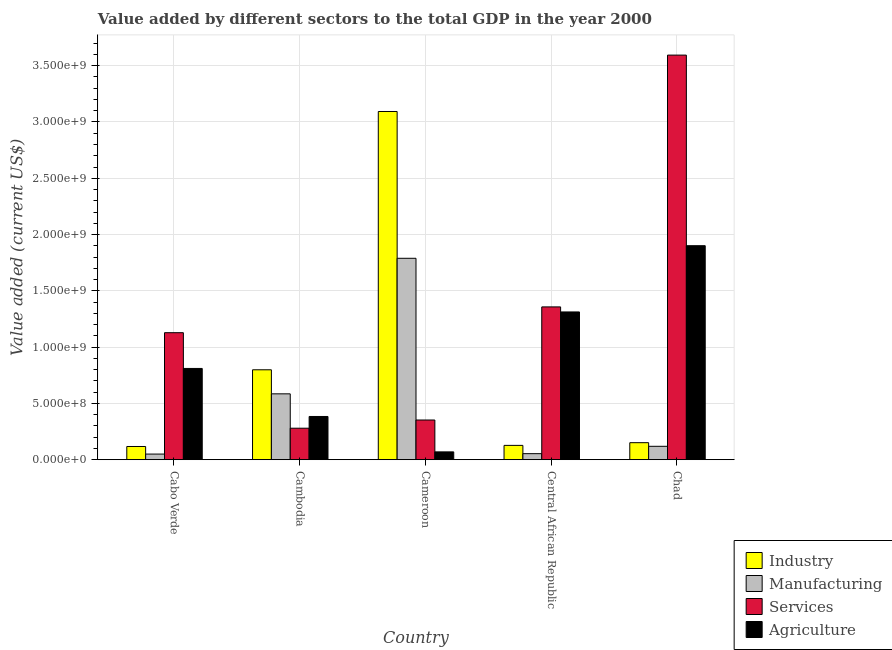How many different coloured bars are there?
Your response must be concise. 4. How many groups of bars are there?
Your response must be concise. 5. Are the number of bars on each tick of the X-axis equal?
Your answer should be very brief. Yes. What is the label of the 3rd group of bars from the left?
Keep it short and to the point. Cameroon. What is the value added by agricultural sector in Cabo Verde?
Give a very brief answer. 8.11e+08. Across all countries, what is the maximum value added by services sector?
Make the answer very short. 3.59e+09. Across all countries, what is the minimum value added by industrial sector?
Offer a terse response. 1.17e+08. In which country was the value added by services sector maximum?
Your answer should be compact. Chad. In which country was the value added by services sector minimum?
Make the answer very short. Cambodia. What is the total value added by services sector in the graph?
Offer a very short reply. 6.71e+09. What is the difference between the value added by services sector in Cambodia and that in Central African Republic?
Offer a terse response. -1.08e+09. What is the difference between the value added by manufacturing sector in Cambodia and the value added by industrial sector in Central African Republic?
Provide a short and direct response. 4.58e+08. What is the average value added by industrial sector per country?
Ensure brevity in your answer.  8.57e+08. What is the difference between the value added by industrial sector and value added by agricultural sector in Central African Republic?
Make the answer very short. -1.19e+09. In how many countries, is the value added by manufacturing sector greater than 1700000000 US$?
Your answer should be compact. 1. What is the ratio of the value added by manufacturing sector in Cambodia to that in Cameroon?
Your response must be concise. 0.33. What is the difference between the highest and the second highest value added by manufacturing sector?
Provide a succinct answer. 1.20e+09. What is the difference between the highest and the lowest value added by services sector?
Your answer should be very brief. 3.31e+09. Is the sum of the value added by manufacturing sector in Cabo Verde and Chad greater than the maximum value added by agricultural sector across all countries?
Provide a short and direct response. No. What does the 2nd bar from the left in Cambodia represents?
Give a very brief answer. Manufacturing. What does the 2nd bar from the right in Cabo Verde represents?
Your answer should be compact. Services. How many bars are there?
Offer a very short reply. 20. Are all the bars in the graph horizontal?
Make the answer very short. No. How many countries are there in the graph?
Provide a short and direct response. 5. Are the values on the major ticks of Y-axis written in scientific E-notation?
Your answer should be very brief. Yes. Does the graph contain any zero values?
Keep it short and to the point. No. Does the graph contain grids?
Your answer should be compact. Yes. What is the title of the graph?
Your answer should be very brief. Value added by different sectors to the total GDP in the year 2000. What is the label or title of the X-axis?
Keep it short and to the point. Country. What is the label or title of the Y-axis?
Your response must be concise. Value added (current US$). What is the Value added (current US$) of Industry in Cabo Verde?
Provide a succinct answer. 1.17e+08. What is the Value added (current US$) in Manufacturing in Cabo Verde?
Make the answer very short. 4.99e+07. What is the Value added (current US$) of Services in Cabo Verde?
Offer a very short reply. 1.13e+09. What is the Value added (current US$) in Agriculture in Cabo Verde?
Offer a very short reply. 8.11e+08. What is the Value added (current US$) of Industry in Cambodia?
Provide a succinct answer. 7.99e+08. What is the Value added (current US$) of Manufacturing in Cambodia?
Make the answer very short. 5.85e+08. What is the Value added (current US$) in Services in Cambodia?
Keep it short and to the point. 2.80e+08. What is the Value added (current US$) of Agriculture in Cambodia?
Your response must be concise. 3.84e+08. What is the Value added (current US$) of Industry in Cameroon?
Give a very brief answer. 3.09e+09. What is the Value added (current US$) in Manufacturing in Cameroon?
Offer a terse response. 1.79e+09. What is the Value added (current US$) in Services in Cameroon?
Your answer should be compact. 3.53e+08. What is the Value added (current US$) of Agriculture in Cameroon?
Offer a terse response. 6.94e+07. What is the Value added (current US$) of Industry in Central African Republic?
Your response must be concise. 1.27e+08. What is the Value added (current US$) of Manufacturing in Central African Republic?
Your response must be concise. 5.35e+07. What is the Value added (current US$) of Services in Central African Republic?
Provide a short and direct response. 1.36e+09. What is the Value added (current US$) in Agriculture in Central African Republic?
Ensure brevity in your answer.  1.31e+09. What is the Value added (current US$) of Industry in Chad?
Offer a terse response. 1.51e+08. What is the Value added (current US$) in Manufacturing in Chad?
Give a very brief answer. 1.19e+08. What is the Value added (current US$) in Services in Chad?
Ensure brevity in your answer.  3.59e+09. What is the Value added (current US$) of Agriculture in Chad?
Ensure brevity in your answer.  1.90e+09. Across all countries, what is the maximum Value added (current US$) in Industry?
Offer a very short reply. 3.09e+09. Across all countries, what is the maximum Value added (current US$) of Manufacturing?
Provide a short and direct response. 1.79e+09. Across all countries, what is the maximum Value added (current US$) of Services?
Provide a short and direct response. 3.59e+09. Across all countries, what is the maximum Value added (current US$) in Agriculture?
Your response must be concise. 1.90e+09. Across all countries, what is the minimum Value added (current US$) in Industry?
Keep it short and to the point. 1.17e+08. Across all countries, what is the minimum Value added (current US$) in Manufacturing?
Keep it short and to the point. 4.99e+07. Across all countries, what is the minimum Value added (current US$) in Services?
Offer a terse response. 2.80e+08. Across all countries, what is the minimum Value added (current US$) of Agriculture?
Provide a short and direct response. 6.94e+07. What is the total Value added (current US$) of Industry in the graph?
Keep it short and to the point. 4.29e+09. What is the total Value added (current US$) in Manufacturing in the graph?
Offer a very short reply. 2.60e+09. What is the total Value added (current US$) of Services in the graph?
Give a very brief answer. 6.71e+09. What is the total Value added (current US$) of Agriculture in the graph?
Offer a very short reply. 4.48e+09. What is the difference between the Value added (current US$) of Industry in Cabo Verde and that in Cambodia?
Make the answer very short. -6.81e+08. What is the difference between the Value added (current US$) in Manufacturing in Cabo Verde and that in Cambodia?
Your response must be concise. -5.35e+08. What is the difference between the Value added (current US$) of Services in Cabo Verde and that in Cambodia?
Provide a succinct answer. 8.49e+08. What is the difference between the Value added (current US$) in Agriculture in Cabo Verde and that in Cambodia?
Give a very brief answer. 4.27e+08. What is the difference between the Value added (current US$) in Industry in Cabo Verde and that in Cameroon?
Provide a succinct answer. -2.98e+09. What is the difference between the Value added (current US$) of Manufacturing in Cabo Verde and that in Cameroon?
Your answer should be very brief. -1.74e+09. What is the difference between the Value added (current US$) in Services in Cabo Verde and that in Cameroon?
Your answer should be compact. 7.76e+08. What is the difference between the Value added (current US$) in Agriculture in Cabo Verde and that in Cameroon?
Your answer should be very brief. 7.41e+08. What is the difference between the Value added (current US$) of Industry in Cabo Verde and that in Central African Republic?
Keep it short and to the point. -9.83e+06. What is the difference between the Value added (current US$) in Manufacturing in Cabo Verde and that in Central African Republic?
Your response must be concise. -3.60e+06. What is the difference between the Value added (current US$) in Services in Cabo Verde and that in Central African Republic?
Provide a succinct answer. -2.29e+08. What is the difference between the Value added (current US$) in Agriculture in Cabo Verde and that in Central African Republic?
Make the answer very short. -5.02e+08. What is the difference between the Value added (current US$) in Industry in Cabo Verde and that in Chad?
Provide a succinct answer. -3.39e+07. What is the difference between the Value added (current US$) of Manufacturing in Cabo Verde and that in Chad?
Your answer should be very brief. -6.90e+07. What is the difference between the Value added (current US$) in Services in Cabo Verde and that in Chad?
Provide a succinct answer. -2.47e+09. What is the difference between the Value added (current US$) of Agriculture in Cabo Verde and that in Chad?
Give a very brief answer. -1.09e+09. What is the difference between the Value added (current US$) in Industry in Cambodia and that in Cameroon?
Offer a very short reply. -2.29e+09. What is the difference between the Value added (current US$) of Manufacturing in Cambodia and that in Cameroon?
Provide a succinct answer. -1.20e+09. What is the difference between the Value added (current US$) of Services in Cambodia and that in Cameroon?
Provide a succinct answer. -7.29e+07. What is the difference between the Value added (current US$) of Agriculture in Cambodia and that in Cameroon?
Offer a terse response. 3.15e+08. What is the difference between the Value added (current US$) in Industry in Cambodia and that in Central African Republic?
Make the answer very short. 6.72e+08. What is the difference between the Value added (current US$) in Manufacturing in Cambodia and that in Central African Republic?
Your answer should be very brief. 5.31e+08. What is the difference between the Value added (current US$) of Services in Cambodia and that in Central African Republic?
Your answer should be very brief. -1.08e+09. What is the difference between the Value added (current US$) of Agriculture in Cambodia and that in Central African Republic?
Your response must be concise. -9.29e+08. What is the difference between the Value added (current US$) in Industry in Cambodia and that in Chad?
Offer a very short reply. 6.48e+08. What is the difference between the Value added (current US$) of Manufacturing in Cambodia and that in Chad?
Provide a short and direct response. 4.66e+08. What is the difference between the Value added (current US$) of Services in Cambodia and that in Chad?
Make the answer very short. -3.31e+09. What is the difference between the Value added (current US$) in Agriculture in Cambodia and that in Chad?
Provide a succinct answer. -1.52e+09. What is the difference between the Value added (current US$) in Industry in Cameroon and that in Central African Republic?
Ensure brevity in your answer.  2.97e+09. What is the difference between the Value added (current US$) of Manufacturing in Cameroon and that in Central African Republic?
Make the answer very short. 1.74e+09. What is the difference between the Value added (current US$) of Services in Cameroon and that in Central African Republic?
Keep it short and to the point. -1.00e+09. What is the difference between the Value added (current US$) of Agriculture in Cameroon and that in Central African Republic?
Keep it short and to the point. -1.24e+09. What is the difference between the Value added (current US$) of Industry in Cameroon and that in Chad?
Ensure brevity in your answer.  2.94e+09. What is the difference between the Value added (current US$) in Manufacturing in Cameroon and that in Chad?
Offer a terse response. 1.67e+09. What is the difference between the Value added (current US$) of Services in Cameroon and that in Chad?
Provide a succinct answer. -3.24e+09. What is the difference between the Value added (current US$) in Agriculture in Cameroon and that in Chad?
Your answer should be very brief. -1.83e+09. What is the difference between the Value added (current US$) of Industry in Central African Republic and that in Chad?
Your response must be concise. -2.40e+07. What is the difference between the Value added (current US$) of Manufacturing in Central African Republic and that in Chad?
Offer a terse response. -6.54e+07. What is the difference between the Value added (current US$) in Services in Central African Republic and that in Chad?
Provide a short and direct response. -2.24e+09. What is the difference between the Value added (current US$) of Agriculture in Central African Republic and that in Chad?
Your answer should be compact. -5.88e+08. What is the difference between the Value added (current US$) in Industry in Cabo Verde and the Value added (current US$) in Manufacturing in Cambodia?
Your response must be concise. -4.68e+08. What is the difference between the Value added (current US$) of Industry in Cabo Verde and the Value added (current US$) of Services in Cambodia?
Provide a succinct answer. -1.62e+08. What is the difference between the Value added (current US$) of Industry in Cabo Verde and the Value added (current US$) of Agriculture in Cambodia?
Provide a short and direct response. -2.67e+08. What is the difference between the Value added (current US$) of Manufacturing in Cabo Verde and the Value added (current US$) of Services in Cambodia?
Your answer should be compact. -2.30e+08. What is the difference between the Value added (current US$) of Manufacturing in Cabo Verde and the Value added (current US$) of Agriculture in Cambodia?
Your answer should be compact. -3.34e+08. What is the difference between the Value added (current US$) of Services in Cabo Verde and the Value added (current US$) of Agriculture in Cambodia?
Your answer should be very brief. 7.44e+08. What is the difference between the Value added (current US$) in Industry in Cabo Verde and the Value added (current US$) in Manufacturing in Cameroon?
Make the answer very short. -1.67e+09. What is the difference between the Value added (current US$) in Industry in Cabo Verde and the Value added (current US$) in Services in Cameroon?
Provide a short and direct response. -2.35e+08. What is the difference between the Value added (current US$) of Industry in Cabo Verde and the Value added (current US$) of Agriculture in Cameroon?
Give a very brief answer. 4.79e+07. What is the difference between the Value added (current US$) of Manufacturing in Cabo Verde and the Value added (current US$) of Services in Cameroon?
Provide a short and direct response. -3.03e+08. What is the difference between the Value added (current US$) in Manufacturing in Cabo Verde and the Value added (current US$) in Agriculture in Cameroon?
Make the answer very short. -1.95e+07. What is the difference between the Value added (current US$) of Services in Cabo Verde and the Value added (current US$) of Agriculture in Cameroon?
Your answer should be very brief. 1.06e+09. What is the difference between the Value added (current US$) of Industry in Cabo Verde and the Value added (current US$) of Manufacturing in Central African Republic?
Your response must be concise. 6.37e+07. What is the difference between the Value added (current US$) of Industry in Cabo Verde and the Value added (current US$) of Services in Central African Republic?
Provide a succinct answer. -1.24e+09. What is the difference between the Value added (current US$) in Industry in Cabo Verde and the Value added (current US$) in Agriculture in Central African Republic?
Provide a succinct answer. -1.20e+09. What is the difference between the Value added (current US$) in Manufacturing in Cabo Verde and the Value added (current US$) in Services in Central African Republic?
Ensure brevity in your answer.  -1.31e+09. What is the difference between the Value added (current US$) of Manufacturing in Cabo Verde and the Value added (current US$) of Agriculture in Central African Republic?
Keep it short and to the point. -1.26e+09. What is the difference between the Value added (current US$) in Services in Cabo Verde and the Value added (current US$) in Agriculture in Central African Republic?
Provide a short and direct response. -1.84e+08. What is the difference between the Value added (current US$) in Industry in Cabo Verde and the Value added (current US$) in Manufacturing in Chad?
Your answer should be compact. -1.68e+06. What is the difference between the Value added (current US$) of Industry in Cabo Verde and the Value added (current US$) of Services in Chad?
Make the answer very short. -3.48e+09. What is the difference between the Value added (current US$) of Industry in Cabo Verde and the Value added (current US$) of Agriculture in Chad?
Your response must be concise. -1.78e+09. What is the difference between the Value added (current US$) in Manufacturing in Cabo Verde and the Value added (current US$) in Services in Chad?
Keep it short and to the point. -3.54e+09. What is the difference between the Value added (current US$) of Manufacturing in Cabo Verde and the Value added (current US$) of Agriculture in Chad?
Your answer should be compact. -1.85e+09. What is the difference between the Value added (current US$) of Services in Cabo Verde and the Value added (current US$) of Agriculture in Chad?
Offer a very short reply. -7.73e+08. What is the difference between the Value added (current US$) in Industry in Cambodia and the Value added (current US$) in Manufacturing in Cameroon?
Make the answer very short. -9.90e+08. What is the difference between the Value added (current US$) in Industry in Cambodia and the Value added (current US$) in Services in Cameroon?
Your answer should be compact. 4.46e+08. What is the difference between the Value added (current US$) in Industry in Cambodia and the Value added (current US$) in Agriculture in Cameroon?
Offer a very short reply. 7.29e+08. What is the difference between the Value added (current US$) of Manufacturing in Cambodia and the Value added (current US$) of Services in Cameroon?
Provide a short and direct response. 2.32e+08. What is the difference between the Value added (current US$) of Manufacturing in Cambodia and the Value added (current US$) of Agriculture in Cameroon?
Make the answer very short. 5.16e+08. What is the difference between the Value added (current US$) of Services in Cambodia and the Value added (current US$) of Agriculture in Cameroon?
Your answer should be very brief. 2.10e+08. What is the difference between the Value added (current US$) in Industry in Cambodia and the Value added (current US$) in Manufacturing in Central African Republic?
Keep it short and to the point. 7.45e+08. What is the difference between the Value added (current US$) in Industry in Cambodia and the Value added (current US$) in Services in Central African Republic?
Your answer should be compact. -5.59e+08. What is the difference between the Value added (current US$) of Industry in Cambodia and the Value added (current US$) of Agriculture in Central African Republic?
Ensure brevity in your answer.  -5.14e+08. What is the difference between the Value added (current US$) of Manufacturing in Cambodia and the Value added (current US$) of Services in Central African Republic?
Your answer should be compact. -7.72e+08. What is the difference between the Value added (current US$) of Manufacturing in Cambodia and the Value added (current US$) of Agriculture in Central African Republic?
Provide a succinct answer. -7.27e+08. What is the difference between the Value added (current US$) of Services in Cambodia and the Value added (current US$) of Agriculture in Central African Republic?
Ensure brevity in your answer.  -1.03e+09. What is the difference between the Value added (current US$) in Industry in Cambodia and the Value added (current US$) in Manufacturing in Chad?
Your response must be concise. 6.80e+08. What is the difference between the Value added (current US$) of Industry in Cambodia and the Value added (current US$) of Services in Chad?
Provide a short and direct response. -2.80e+09. What is the difference between the Value added (current US$) of Industry in Cambodia and the Value added (current US$) of Agriculture in Chad?
Provide a succinct answer. -1.10e+09. What is the difference between the Value added (current US$) in Manufacturing in Cambodia and the Value added (current US$) in Services in Chad?
Your response must be concise. -3.01e+09. What is the difference between the Value added (current US$) in Manufacturing in Cambodia and the Value added (current US$) in Agriculture in Chad?
Your answer should be compact. -1.32e+09. What is the difference between the Value added (current US$) in Services in Cambodia and the Value added (current US$) in Agriculture in Chad?
Make the answer very short. -1.62e+09. What is the difference between the Value added (current US$) of Industry in Cameroon and the Value added (current US$) of Manufacturing in Central African Republic?
Provide a short and direct response. 3.04e+09. What is the difference between the Value added (current US$) in Industry in Cameroon and the Value added (current US$) in Services in Central African Republic?
Your answer should be very brief. 1.74e+09. What is the difference between the Value added (current US$) of Industry in Cameroon and the Value added (current US$) of Agriculture in Central African Republic?
Your response must be concise. 1.78e+09. What is the difference between the Value added (current US$) in Manufacturing in Cameroon and the Value added (current US$) in Services in Central African Republic?
Ensure brevity in your answer.  4.32e+08. What is the difference between the Value added (current US$) of Manufacturing in Cameroon and the Value added (current US$) of Agriculture in Central African Republic?
Give a very brief answer. 4.77e+08. What is the difference between the Value added (current US$) of Services in Cameroon and the Value added (current US$) of Agriculture in Central African Republic?
Provide a short and direct response. -9.60e+08. What is the difference between the Value added (current US$) of Industry in Cameroon and the Value added (current US$) of Manufacturing in Chad?
Offer a very short reply. 2.97e+09. What is the difference between the Value added (current US$) in Industry in Cameroon and the Value added (current US$) in Services in Chad?
Provide a short and direct response. -5.01e+08. What is the difference between the Value added (current US$) in Industry in Cameroon and the Value added (current US$) in Agriculture in Chad?
Offer a terse response. 1.19e+09. What is the difference between the Value added (current US$) in Manufacturing in Cameroon and the Value added (current US$) in Services in Chad?
Your answer should be compact. -1.80e+09. What is the difference between the Value added (current US$) in Manufacturing in Cameroon and the Value added (current US$) in Agriculture in Chad?
Your response must be concise. -1.12e+08. What is the difference between the Value added (current US$) in Services in Cameroon and the Value added (current US$) in Agriculture in Chad?
Provide a short and direct response. -1.55e+09. What is the difference between the Value added (current US$) of Industry in Central African Republic and the Value added (current US$) of Manufacturing in Chad?
Offer a terse response. 8.15e+06. What is the difference between the Value added (current US$) in Industry in Central African Republic and the Value added (current US$) in Services in Chad?
Offer a terse response. -3.47e+09. What is the difference between the Value added (current US$) in Industry in Central African Republic and the Value added (current US$) in Agriculture in Chad?
Your answer should be compact. -1.77e+09. What is the difference between the Value added (current US$) in Manufacturing in Central African Republic and the Value added (current US$) in Services in Chad?
Give a very brief answer. -3.54e+09. What is the difference between the Value added (current US$) of Manufacturing in Central African Republic and the Value added (current US$) of Agriculture in Chad?
Your response must be concise. -1.85e+09. What is the difference between the Value added (current US$) of Services in Central African Republic and the Value added (current US$) of Agriculture in Chad?
Ensure brevity in your answer.  -5.44e+08. What is the average Value added (current US$) of Industry per country?
Keep it short and to the point. 8.57e+08. What is the average Value added (current US$) in Manufacturing per country?
Provide a short and direct response. 5.19e+08. What is the average Value added (current US$) of Services per country?
Provide a succinct answer. 1.34e+09. What is the average Value added (current US$) in Agriculture per country?
Offer a terse response. 8.95e+08. What is the difference between the Value added (current US$) of Industry and Value added (current US$) of Manufacturing in Cabo Verde?
Make the answer very short. 6.73e+07. What is the difference between the Value added (current US$) in Industry and Value added (current US$) in Services in Cabo Verde?
Ensure brevity in your answer.  -1.01e+09. What is the difference between the Value added (current US$) in Industry and Value added (current US$) in Agriculture in Cabo Verde?
Ensure brevity in your answer.  -6.93e+08. What is the difference between the Value added (current US$) of Manufacturing and Value added (current US$) of Services in Cabo Verde?
Give a very brief answer. -1.08e+09. What is the difference between the Value added (current US$) of Manufacturing and Value added (current US$) of Agriculture in Cabo Verde?
Your answer should be compact. -7.61e+08. What is the difference between the Value added (current US$) of Services and Value added (current US$) of Agriculture in Cabo Verde?
Ensure brevity in your answer.  3.18e+08. What is the difference between the Value added (current US$) of Industry and Value added (current US$) of Manufacturing in Cambodia?
Ensure brevity in your answer.  2.14e+08. What is the difference between the Value added (current US$) of Industry and Value added (current US$) of Services in Cambodia?
Offer a terse response. 5.19e+08. What is the difference between the Value added (current US$) in Industry and Value added (current US$) in Agriculture in Cambodia?
Your answer should be very brief. 4.15e+08. What is the difference between the Value added (current US$) in Manufacturing and Value added (current US$) in Services in Cambodia?
Your answer should be very brief. 3.05e+08. What is the difference between the Value added (current US$) in Manufacturing and Value added (current US$) in Agriculture in Cambodia?
Make the answer very short. 2.01e+08. What is the difference between the Value added (current US$) of Services and Value added (current US$) of Agriculture in Cambodia?
Keep it short and to the point. -1.04e+08. What is the difference between the Value added (current US$) in Industry and Value added (current US$) in Manufacturing in Cameroon?
Your answer should be compact. 1.30e+09. What is the difference between the Value added (current US$) of Industry and Value added (current US$) of Services in Cameroon?
Provide a succinct answer. 2.74e+09. What is the difference between the Value added (current US$) of Industry and Value added (current US$) of Agriculture in Cameroon?
Provide a succinct answer. 3.02e+09. What is the difference between the Value added (current US$) in Manufacturing and Value added (current US$) in Services in Cameroon?
Provide a short and direct response. 1.44e+09. What is the difference between the Value added (current US$) of Manufacturing and Value added (current US$) of Agriculture in Cameroon?
Ensure brevity in your answer.  1.72e+09. What is the difference between the Value added (current US$) in Services and Value added (current US$) in Agriculture in Cameroon?
Keep it short and to the point. 2.83e+08. What is the difference between the Value added (current US$) of Industry and Value added (current US$) of Manufacturing in Central African Republic?
Ensure brevity in your answer.  7.36e+07. What is the difference between the Value added (current US$) of Industry and Value added (current US$) of Services in Central African Republic?
Offer a terse response. -1.23e+09. What is the difference between the Value added (current US$) of Industry and Value added (current US$) of Agriculture in Central African Republic?
Offer a very short reply. -1.19e+09. What is the difference between the Value added (current US$) in Manufacturing and Value added (current US$) in Services in Central African Republic?
Offer a terse response. -1.30e+09. What is the difference between the Value added (current US$) of Manufacturing and Value added (current US$) of Agriculture in Central African Republic?
Offer a very short reply. -1.26e+09. What is the difference between the Value added (current US$) in Services and Value added (current US$) in Agriculture in Central African Republic?
Your response must be concise. 4.48e+07. What is the difference between the Value added (current US$) of Industry and Value added (current US$) of Manufacturing in Chad?
Keep it short and to the point. 3.22e+07. What is the difference between the Value added (current US$) of Industry and Value added (current US$) of Services in Chad?
Offer a terse response. -3.44e+09. What is the difference between the Value added (current US$) of Industry and Value added (current US$) of Agriculture in Chad?
Give a very brief answer. -1.75e+09. What is the difference between the Value added (current US$) of Manufacturing and Value added (current US$) of Services in Chad?
Offer a terse response. -3.48e+09. What is the difference between the Value added (current US$) in Manufacturing and Value added (current US$) in Agriculture in Chad?
Offer a very short reply. -1.78e+09. What is the difference between the Value added (current US$) in Services and Value added (current US$) in Agriculture in Chad?
Give a very brief answer. 1.69e+09. What is the ratio of the Value added (current US$) in Industry in Cabo Verde to that in Cambodia?
Offer a very short reply. 0.15. What is the ratio of the Value added (current US$) of Manufacturing in Cabo Verde to that in Cambodia?
Provide a short and direct response. 0.09. What is the ratio of the Value added (current US$) in Services in Cabo Verde to that in Cambodia?
Make the answer very short. 4.03. What is the ratio of the Value added (current US$) of Agriculture in Cabo Verde to that in Cambodia?
Keep it short and to the point. 2.11. What is the ratio of the Value added (current US$) in Industry in Cabo Verde to that in Cameroon?
Your response must be concise. 0.04. What is the ratio of the Value added (current US$) of Manufacturing in Cabo Verde to that in Cameroon?
Offer a terse response. 0.03. What is the ratio of the Value added (current US$) in Services in Cabo Verde to that in Cameroon?
Make the answer very short. 3.2. What is the ratio of the Value added (current US$) of Agriculture in Cabo Verde to that in Cameroon?
Make the answer very short. 11.68. What is the ratio of the Value added (current US$) of Industry in Cabo Verde to that in Central African Republic?
Provide a succinct answer. 0.92. What is the ratio of the Value added (current US$) of Manufacturing in Cabo Verde to that in Central African Republic?
Keep it short and to the point. 0.93. What is the ratio of the Value added (current US$) of Services in Cabo Verde to that in Central African Republic?
Provide a short and direct response. 0.83. What is the ratio of the Value added (current US$) in Agriculture in Cabo Verde to that in Central African Republic?
Offer a terse response. 0.62. What is the ratio of the Value added (current US$) of Industry in Cabo Verde to that in Chad?
Your response must be concise. 0.78. What is the ratio of the Value added (current US$) in Manufacturing in Cabo Verde to that in Chad?
Provide a succinct answer. 0.42. What is the ratio of the Value added (current US$) in Services in Cabo Verde to that in Chad?
Make the answer very short. 0.31. What is the ratio of the Value added (current US$) in Agriculture in Cabo Verde to that in Chad?
Provide a short and direct response. 0.43. What is the ratio of the Value added (current US$) in Industry in Cambodia to that in Cameroon?
Give a very brief answer. 0.26. What is the ratio of the Value added (current US$) of Manufacturing in Cambodia to that in Cameroon?
Give a very brief answer. 0.33. What is the ratio of the Value added (current US$) in Services in Cambodia to that in Cameroon?
Give a very brief answer. 0.79. What is the ratio of the Value added (current US$) in Agriculture in Cambodia to that in Cameroon?
Provide a short and direct response. 5.53. What is the ratio of the Value added (current US$) of Industry in Cambodia to that in Central African Republic?
Provide a succinct answer. 6.28. What is the ratio of the Value added (current US$) of Manufacturing in Cambodia to that in Central African Republic?
Keep it short and to the point. 10.93. What is the ratio of the Value added (current US$) in Services in Cambodia to that in Central African Republic?
Ensure brevity in your answer.  0.21. What is the ratio of the Value added (current US$) of Agriculture in Cambodia to that in Central African Republic?
Provide a short and direct response. 0.29. What is the ratio of the Value added (current US$) of Industry in Cambodia to that in Chad?
Your answer should be compact. 5.28. What is the ratio of the Value added (current US$) in Manufacturing in Cambodia to that in Chad?
Offer a terse response. 4.92. What is the ratio of the Value added (current US$) of Services in Cambodia to that in Chad?
Make the answer very short. 0.08. What is the ratio of the Value added (current US$) in Agriculture in Cambodia to that in Chad?
Make the answer very short. 0.2. What is the ratio of the Value added (current US$) of Industry in Cameroon to that in Central African Republic?
Give a very brief answer. 24.34. What is the ratio of the Value added (current US$) in Manufacturing in Cameroon to that in Central African Republic?
Provide a succinct answer. 33.41. What is the ratio of the Value added (current US$) in Services in Cameroon to that in Central African Republic?
Ensure brevity in your answer.  0.26. What is the ratio of the Value added (current US$) of Agriculture in Cameroon to that in Central African Republic?
Provide a short and direct response. 0.05. What is the ratio of the Value added (current US$) of Industry in Cameroon to that in Chad?
Offer a very short reply. 20.46. What is the ratio of the Value added (current US$) of Manufacturing in Cameroon to that in Chad?
Keep it short and to the point. 15.04. What is the ratio of the Value added (current US$) of Services in Cameroon to that in Chad?
Keep it short and to the point. 0.1. What is the ratio of the Value added (current US$) of Agriculture in Cameroon to that in Chad?
Ensure brevity in your answer.  0.04. What is the ratio of the Value added (current US$) of Industry in Central African Republic to that in Chad?
Offer a terse response. 0.84. What is the ratio of the Value added (current US$) in Manufacturing in Central African Republic to that in Chad?
Your answer should be compact. 0.45. What is the ratio of the Value added (current US$) in Services in Central African Republic to that in Chad?
Your answer should be compact. 0.38. What is the ratio of the Value added (current US$) of Agriculture in Central African Republic to that in Chad?
Offer a terse response. 0.69. What is the difference between the highest and the second highest Value added (current US$) in Industry?
Keep it short and to the point. 2.29e+09. What is the difference between the highest and the second highest Value added (current US$) in Manufacturing?
Your answer should be very brief. 1.20e+09. What is the difference between the highest and the second highest Value added (current US$) in Services?
Ensure brevity in your answer.  2.24e+09. What is the difference between the highest and the second highest Value added (current US$) in Agriculture?
Provide a succinct answer. 5.88e+08. What is the difference between the highest and the lowest Value added (current US$) of Industry?
Provide a succinct answer. 2.98e+09. What is the difference between the highest and the lowest Value added (current US$) of Manufacturing?
Make the answer very short. 1.74e+09. What is the difference between the highest and the lowest Value added (current US$) of Services?
Your answer should be compact. 3.31e+09. What is the difference between the highest and the lowest Value added (current US$) of Agriculture?
Offer a very short reply. 1.83e+09. 